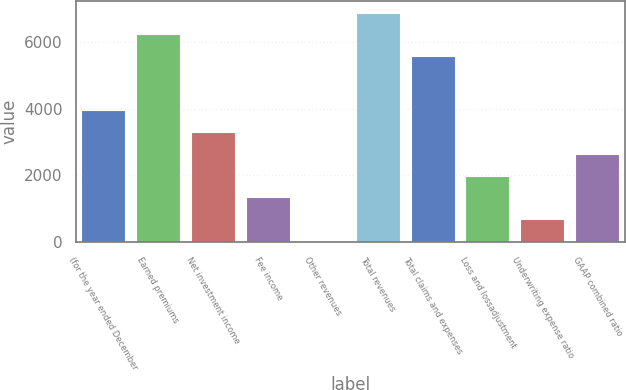<chart> <loc_0><loc_0><loc_500><loc_500><bar_chart><fcel>(for the year ended December<fcel>Earned premiums<fcel>Net investment income<fcel>Fee income<fcel>Other revenues<fcel>Total revenues<fcel>Total claims and expenses<fcel>Loss and lossadjustment<fcel>Underwriting expense ratio<fcel>GAAP combined ratio<nl><fcel>3947.6<fcel>6226.1<fcel>3294.5<fcel>1335.2<fcel>29<fcel>6879.2<fcel>5573<fcel>1988.3<fcel>682.1<fcel>2641.4<nl></chart> 